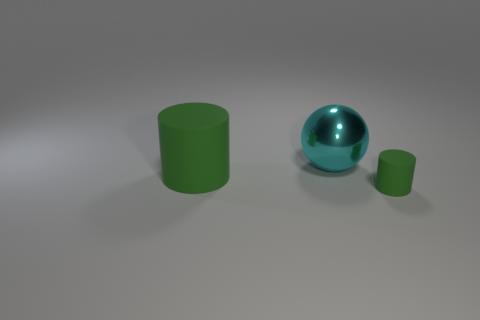Add 1 cyan objects. How many objects exist? 4 Subtract all cylinders. How many objects are left? 1 Add 2 cyan metal objects. How many cyan metal objects exist? 3 Subtract 0 green balls. How many objects are left? 3 Subtract all yellow cylinders. Subtract all purple blocks. How many cylinders are left? 2 Subtract all large cyan spheres. Subtract all big balls. How many objects are left? 1 Add 1 green objects. How many green objects are left? 3 